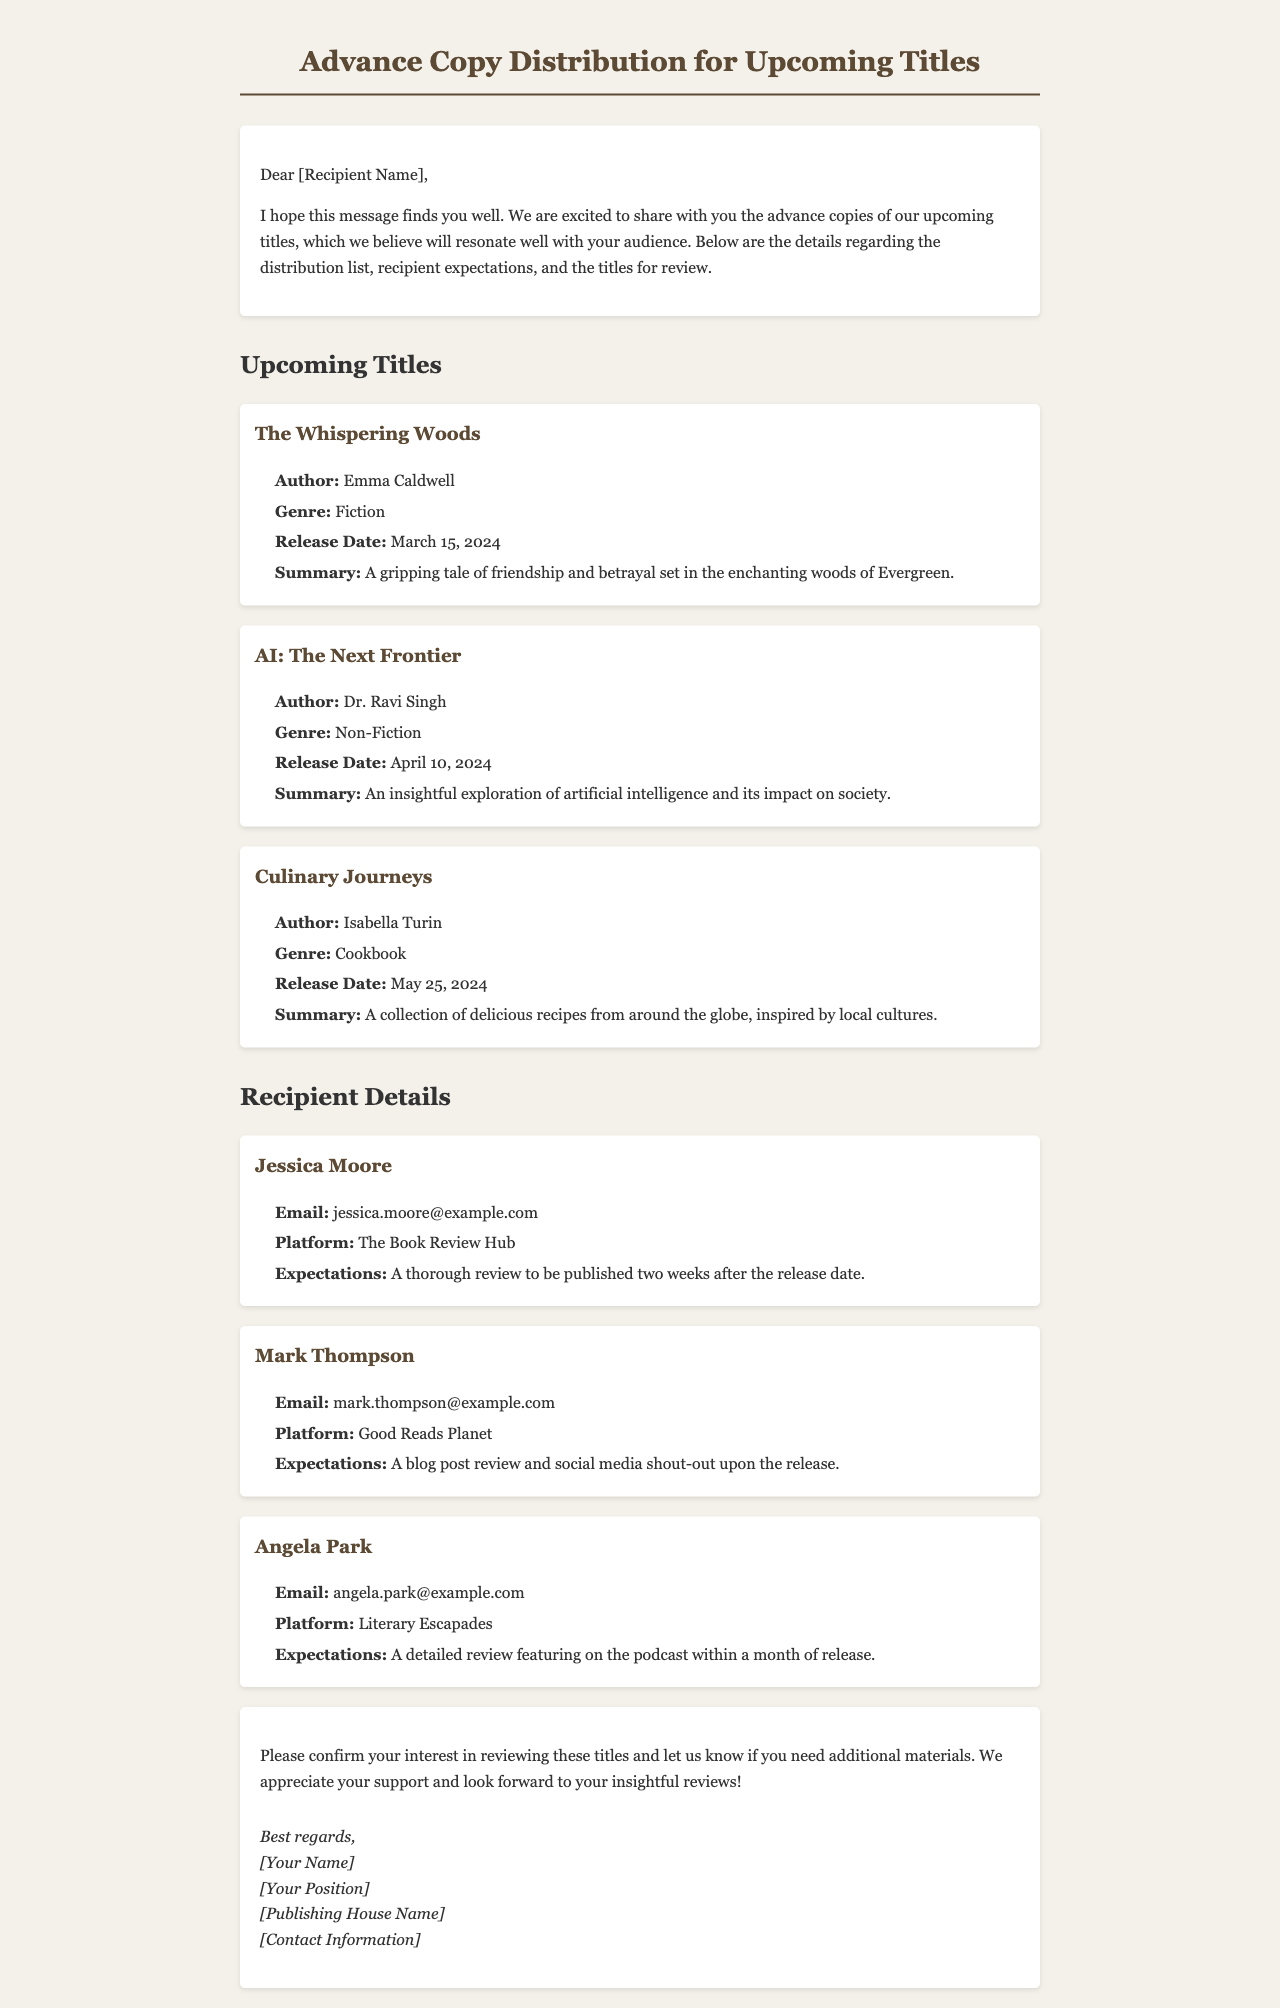What is the title of the first book listed? The first book listed is "The Whispering Woods."
Answer: The Whispering Woods Who is the author of "AI: The Next Frontier"? The author is Dr. Ravi Singh.
Answer: Dr. Ravi Singh What is the release date of "Culinary Journeys"? The release date is May 25, 2024.
Answer: May 25, 2024 What is Jessica Moore's platform for reviews? Jessica Moore's platform is The Book Review Hub.
Answer: The Book Review Hub What type of expectation does Mark Thompson have for his review? Mark Thompson expects a blog post review and social media shout-out.
Answer: A blog post review and social media shout-out How long after the release date does Angela Park need to publish her review? Angela Park needs to publish her review within a month of release.
Answer: Within a month of release What is the genre of "The Whispering Woods"? The genre is Fiction.
Answer: Fiction Who should confirm interest in reviewing the titles? The recipients should confirm their interest.
Answer: The recipients 